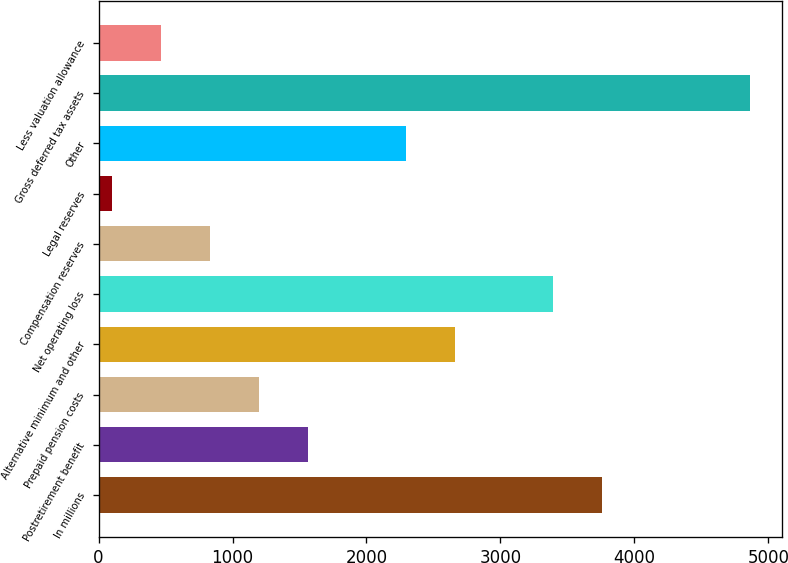Convert chart to OTSL. <chart><loc_0><loc_0><loc_500><loc_500><bar_chart><fcel>In millions<fcel>Postretirement benefit<fcel>Prepaid pension costs<fcel>Alternative minimum and other<fcel>Net operating loss<fcel>Compensation reserves<fcel>Legal reserves<fcel>Other<fcel>Gross deferred tax assets<fcel>Less valuation allowance<nl><fcel>3762<fcel>1563.6<fcel>1197.2<fcel>2662.8<fcel>3395.6<fcel>830.8<fcel>98<fcel>2296.4<fcel>4861.2<fcel>464.4<nl></chart> 